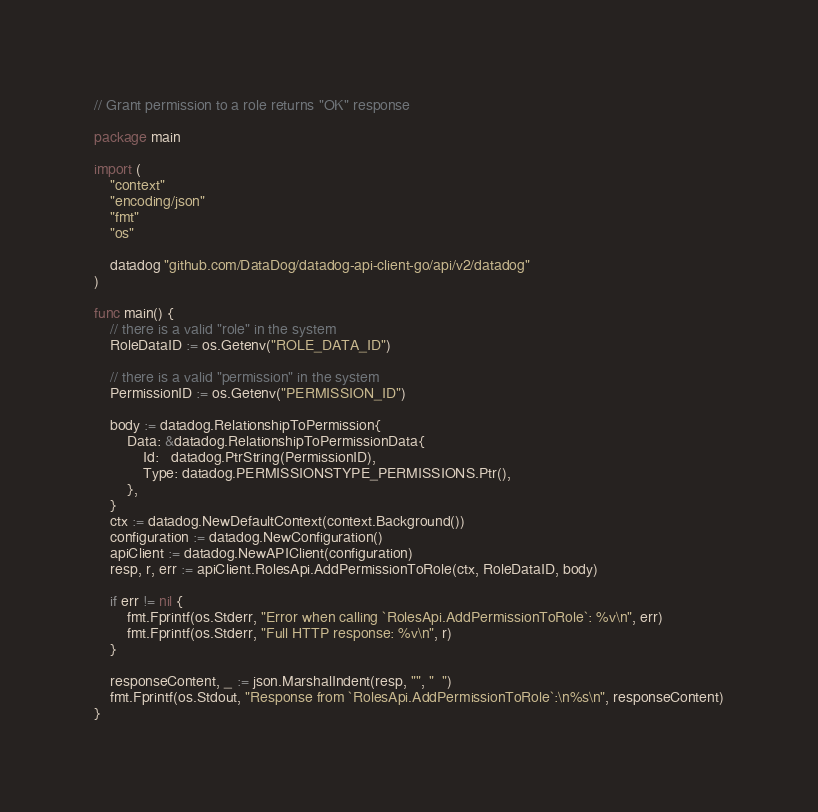Convert code to text. <code><loc_0><loc_0><loc_500><loc_500><_Go_>// Grant permission to a role returns "OK" response

package main

import (
	"context"
	"encoding/json"
	"fmt"
	"os"

	datadog "github.com/DataDog/datadog-api-client-go/api/v2/datadog"
)

func main() {
	// there is a valid "role" in the system
	RoleDataID := os.Getenv("ROLE_DATA_ID")

	// there is a valid "permission" in the system
	PermissionID := os.Getenv("PERMISSION_ID")

	body := datadog.RelationshipToPermission{
		Data: &datadog.RelationshipToPermissionData{
			Id:   datadog.PtrString(PermissionID),
			Type: datadog.PERMISSIONSTYPE_PERMISSIONS.Ptr(),
		},
	}
	ctx := datadog.NewDefaultContext(context.Background())
	configuration := datadog.NewConfiguration()
	apiClient := datadog.NewAPIClient(configuration)
	resp, r, err := apiClient.RolesApi.AddPermissionToRole(ctx, RoleDataID, body)

	if err != nil {
		fmt.Fprintf(os.Stderr, "Error when calling `RolesApi.AddPermissionToRole`: %v\n", err)
		fmt.Fprintf(os.Stderr, "Full HTTP response: %v\n", r)
	}

	responseContent, _ := json.MarshalIndent(resp, "", "  ")
	fmt.Fprintf(os.Stdout, "Response from `RolesApi.AddPermissionToRole`:\n%s\n", responseContent)
}
</code> 